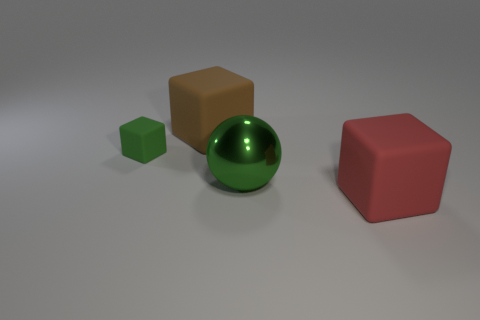What number of other things are there of the same size as the green matte thing?
Provide a short and direct response. 0. The other object that is the same color as the small matte object is what size?
Ensure brevity in your answer.  Large. Do the big red object in front of the shiny sphere and the big metallic thing have the same shape?
Make the answer very short. No. How many other objects are the same shape as the large brown rubber object?
Offer a very short reply. 2. There is a big thing that is in front of the ball; what shape is it?
Provide a succinct answer. Cube. Is there another big object that has the same material as the red object?
Make the answer very short. Yes. Do the ball in front of the tiny green object and the small matte block have the same color?
Keep it short and to the point. Yes. The metal sphere has what size?
Give a very brief answer. Large. There is a green thing left of the green thing in front of the small green thing; are there any large matte things that are behind it?
Give a very brief answer. Yes. How many big matte objects are behind the large metallic thing?
Offer a very short reply. 1. 